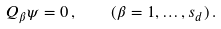Convert formula to latex. <formula><loc_0><loc_0><loc_500><loc_500>Q _ { \beta } \psi = 0 \, , \quad ( \beta = 1 , \dots , s _ { d } ) \, .</formula> 